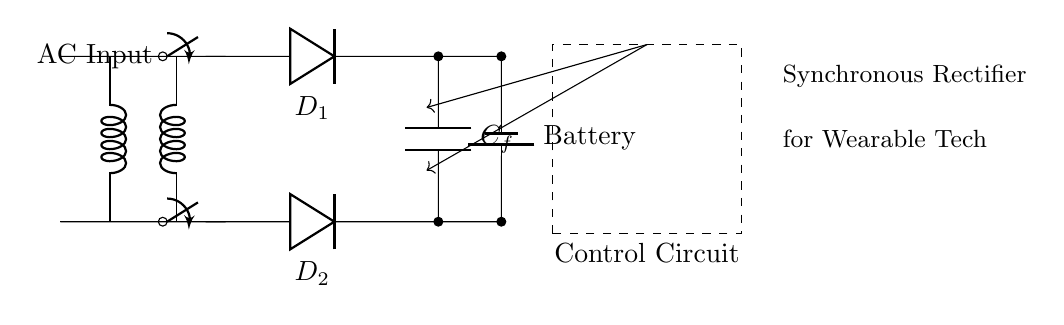What type of rectifier is used in this circuit? The circuit is a synchronous rectifier, which is indicated by the label on the diagram.
Answer: synchronous rectifier What components are used for rectification in this circuit? The rectification is performed by two diodes labeled D1 and D2. They are responsible for converting AC to DC.
Answer: D1 and D2 How many capacitors are in this circuit? There is one capacitor denoted as C_f, which is used for filtering the output voltage.
Answer: one What is the purpose of the transformer in this circuit? The transformer steps down the AC voltage from the input to a suitable level for the rectification, facilitating battery charging.
Answer: steps down AC voltage What is the role of the control circuit in this synchronous rectifier? The control circuit manages the operation of the synchronous rectifier, ensuring efficient switching of the diodes to prevent conduction losses.
Answer: manages diode operation What is the use of the battery in this circuit? The battery is used for storing the rectified DC energy generated by the circuit, making it essential for powering wearable tech.
Answer: energy storage What happens if the diodes are replaced with regular diodes instead of synchronous rectifiers? If regular diodes are used, the overall efficiency decreases due to higher forward voltage drop and increased heat generation during operation.
Answer: efficiency decreases 